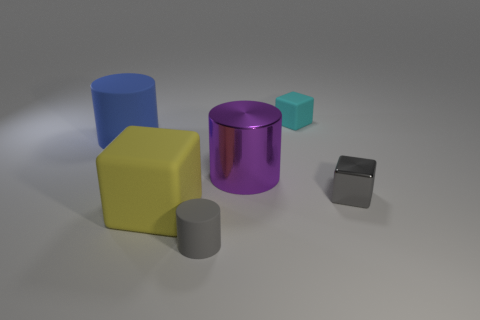Subtract all matte cubes. How many cubes are left? 1 Add 1 cubes. How many objects exist? 7 Subtract 0 gray spheres. How many objects are left? 6 Subtract all green rubber objects. Subtract all cubes. How many objects are left? 3 Add 4 big yellow rubber blocks. How many big yellow rubber blocks are left? 5 Add 5 large red metal spheres. How many large red metal spheres exist? 5 